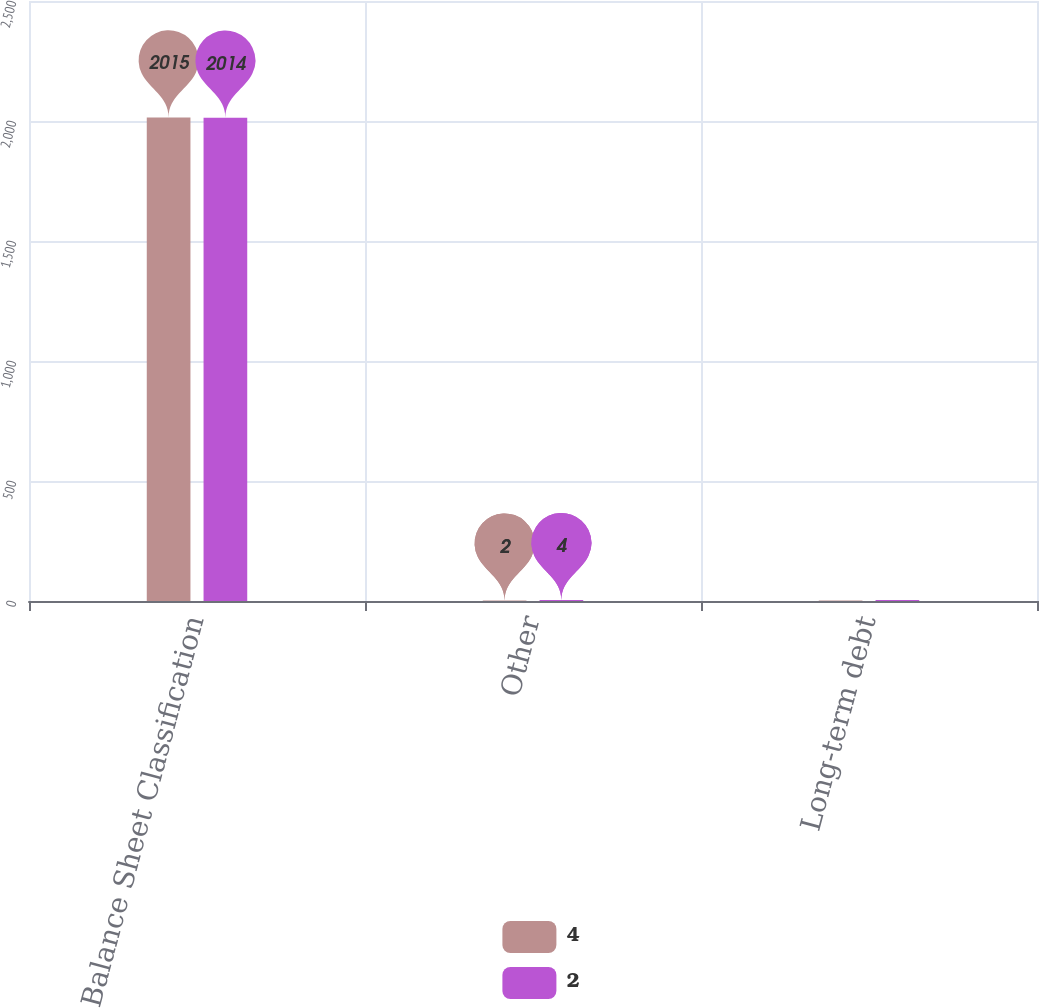Convert chart to OTSL. <chart><loc_0><loc_0><loc_500><loc_500><stacked_bar_chart><ecel><fcel>Balance Sheet Classification<fcel>Other<fcel>Long-term debt<nl><fcel>4<fcel>2015<fcel>2<fcel>2<nl><fcel>2<fcel>2014<fcel>4<fcel>4<nl></chart> 